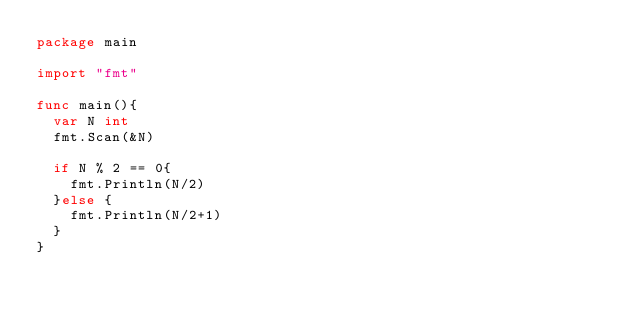Convert code to text. <code><loc_0><loc_0><loc_500><loc_500><_Go_>package main

import "fmt" 

func main(){
	var N int
	fmt.Scan(&N)

	if N % 2 == 0{
		fmt.Println(N/2)
	}else {
		fmt.Println(N/2+1)
	}
}</code> 